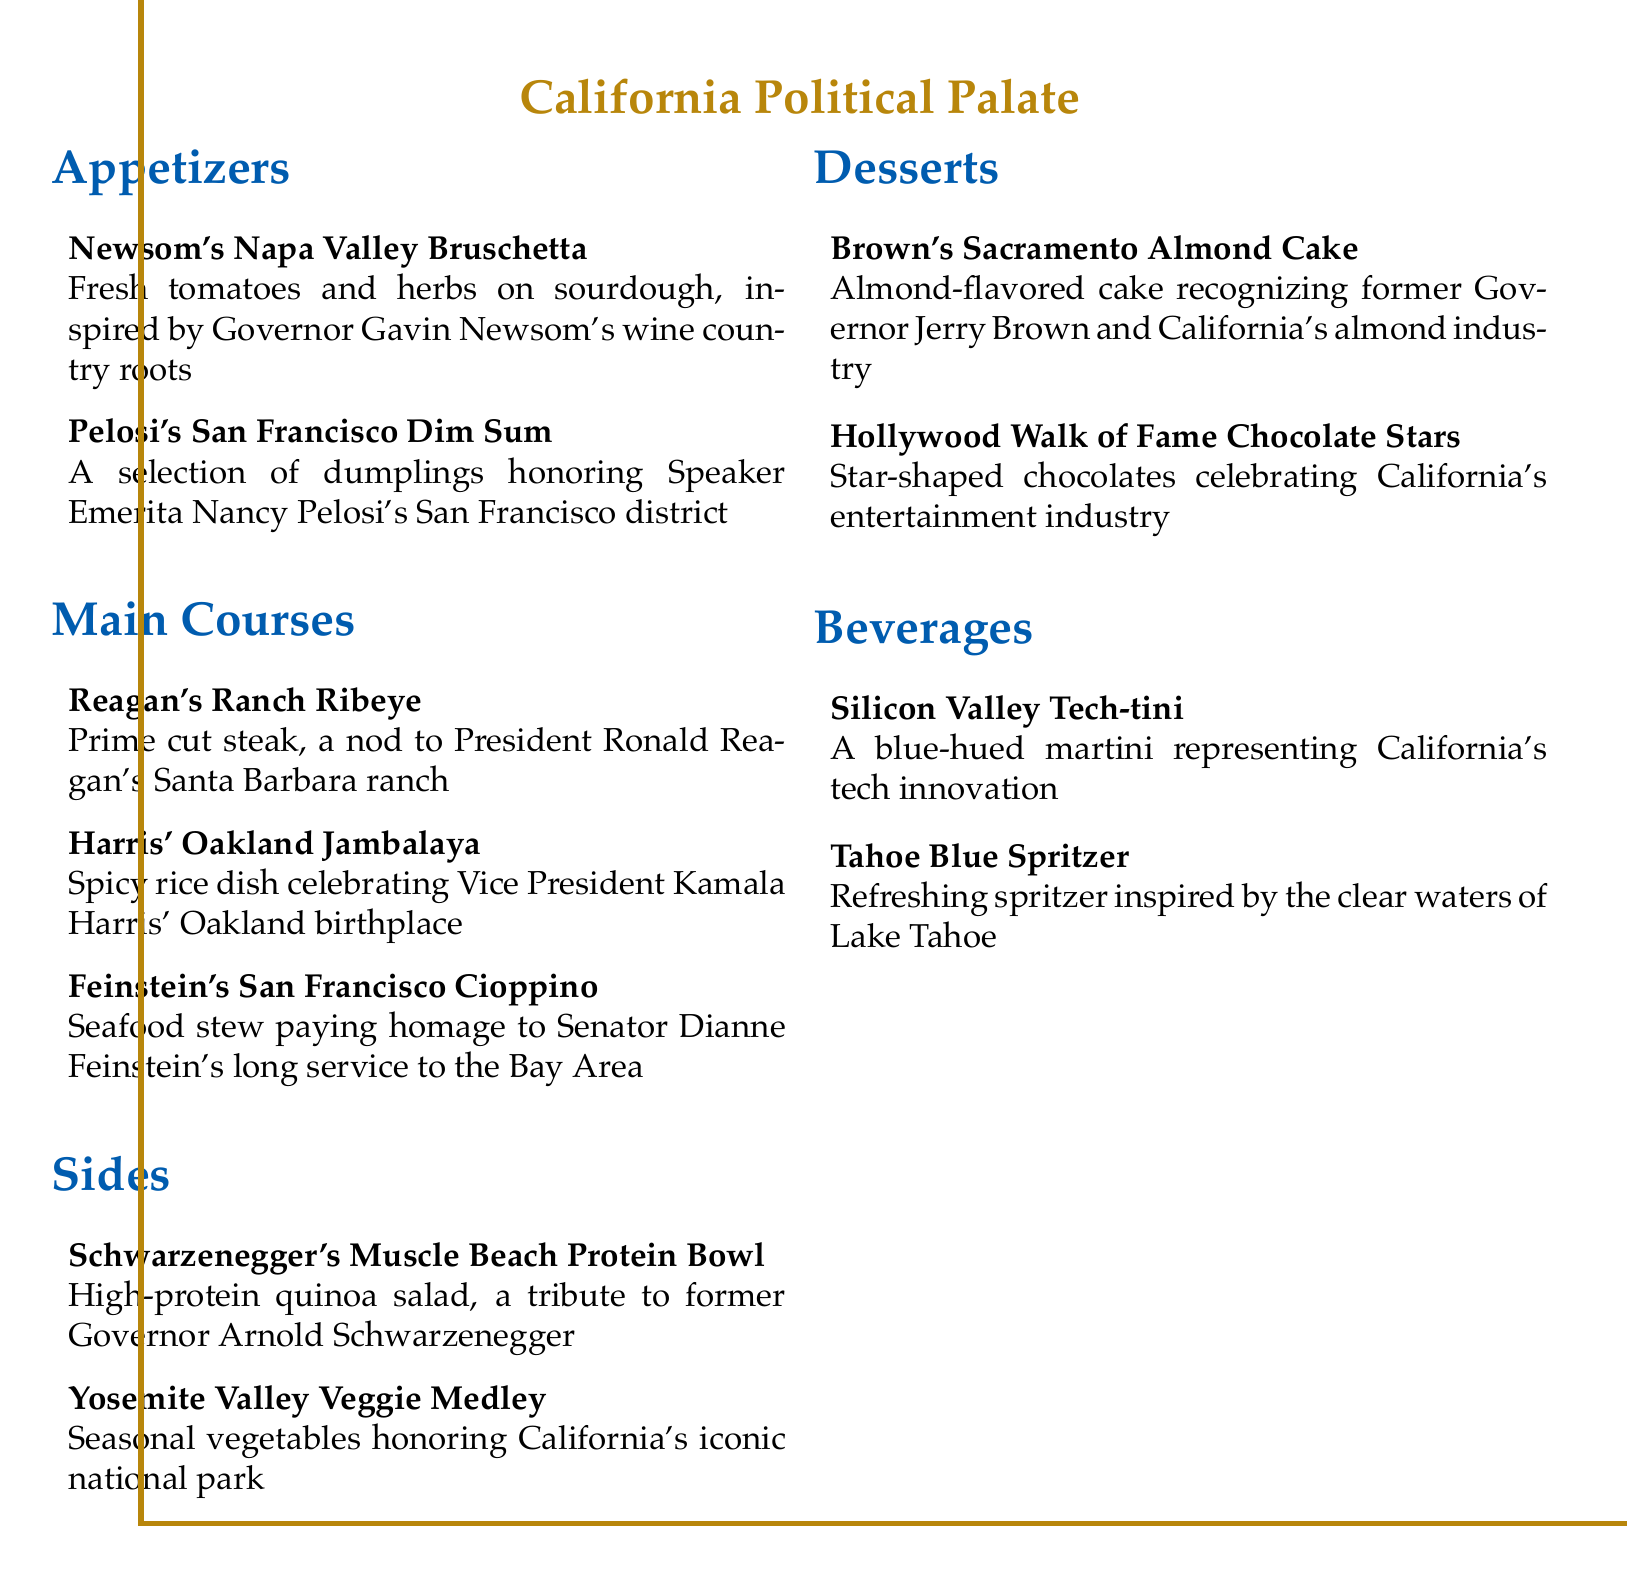What is the name of the dish inspired by Governor Gavin Newsom? The dish inspired by Governor Gavin Newsom is "Newsom's Napa Valley Bruschetta."
Answer: Newsom's Napa Valley Bruschetta Which dessert honors former Governor Jerry Brown? The dessert that honors former Governor Jerry Brown is "Brown's Sacramento Almond Cake."
Answer: Brown's Sacramento Almond Cake What type of drink is the "Silicon Valley Tech-tini"? The "Silicon Valley Tech-tini" is a blue-hued martini.
Answer: Blue-hued martini How many appetizers are listed on the menu? There are two appetizers listed on the menu: Newsom's Napa Valley Bruschetta and Pelosi's San Francisco Dim Sum.
Answer: Two Which dish celebrates Vice President Kamala Harris' birthplace? The dish that celebrates Vice President Kamala Harris' birthplace is "Harris' Oakland Jambalaya."
Answer: Harris' Oakland Jambalaya What food category includes "Yosemite Valley Veggie Medley"? "Yosemite Valley Veggie Medley" is included in the Sides category.
Answer: Sides What is the signature flavor of the cake named after Jerry Brown? The signature flavor of the cake is almond.
Answer: Almond Which dish is a seafood stew? The dish that is a seafood stew is "Feinstein's San Francisco Cioppino."
Answer: Feinstein's San Francisco Cioppino 